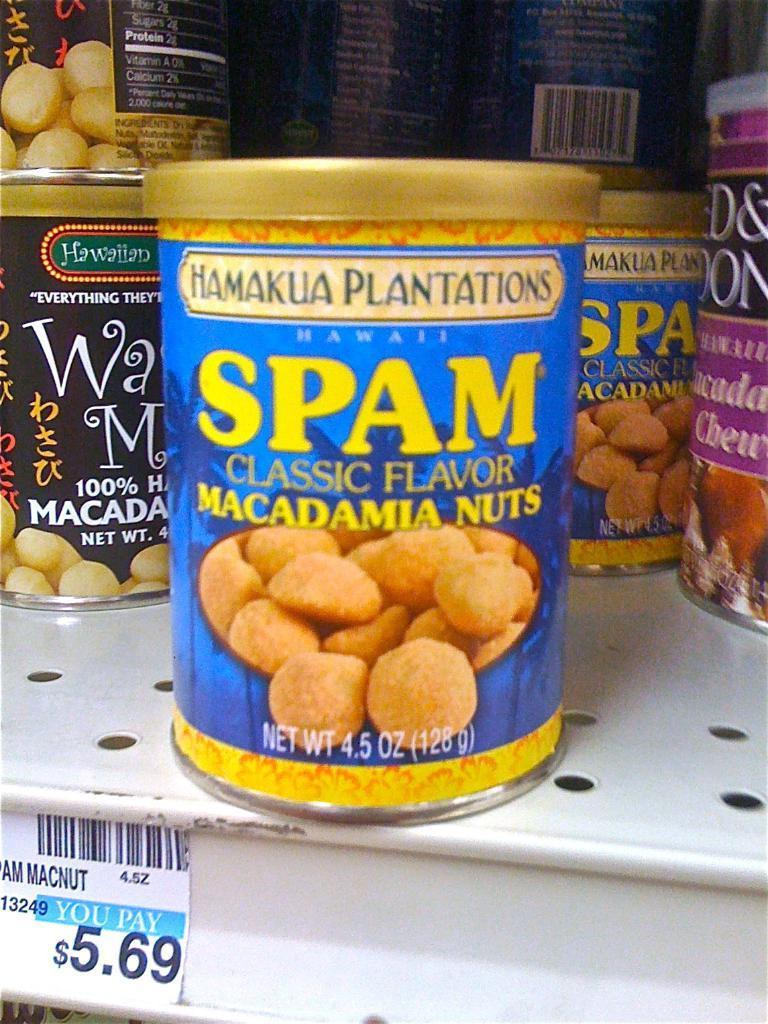Could you give a brief overview of what you see in this image? In this picture I can see food cans on an iron object, and there is a price sticker. 